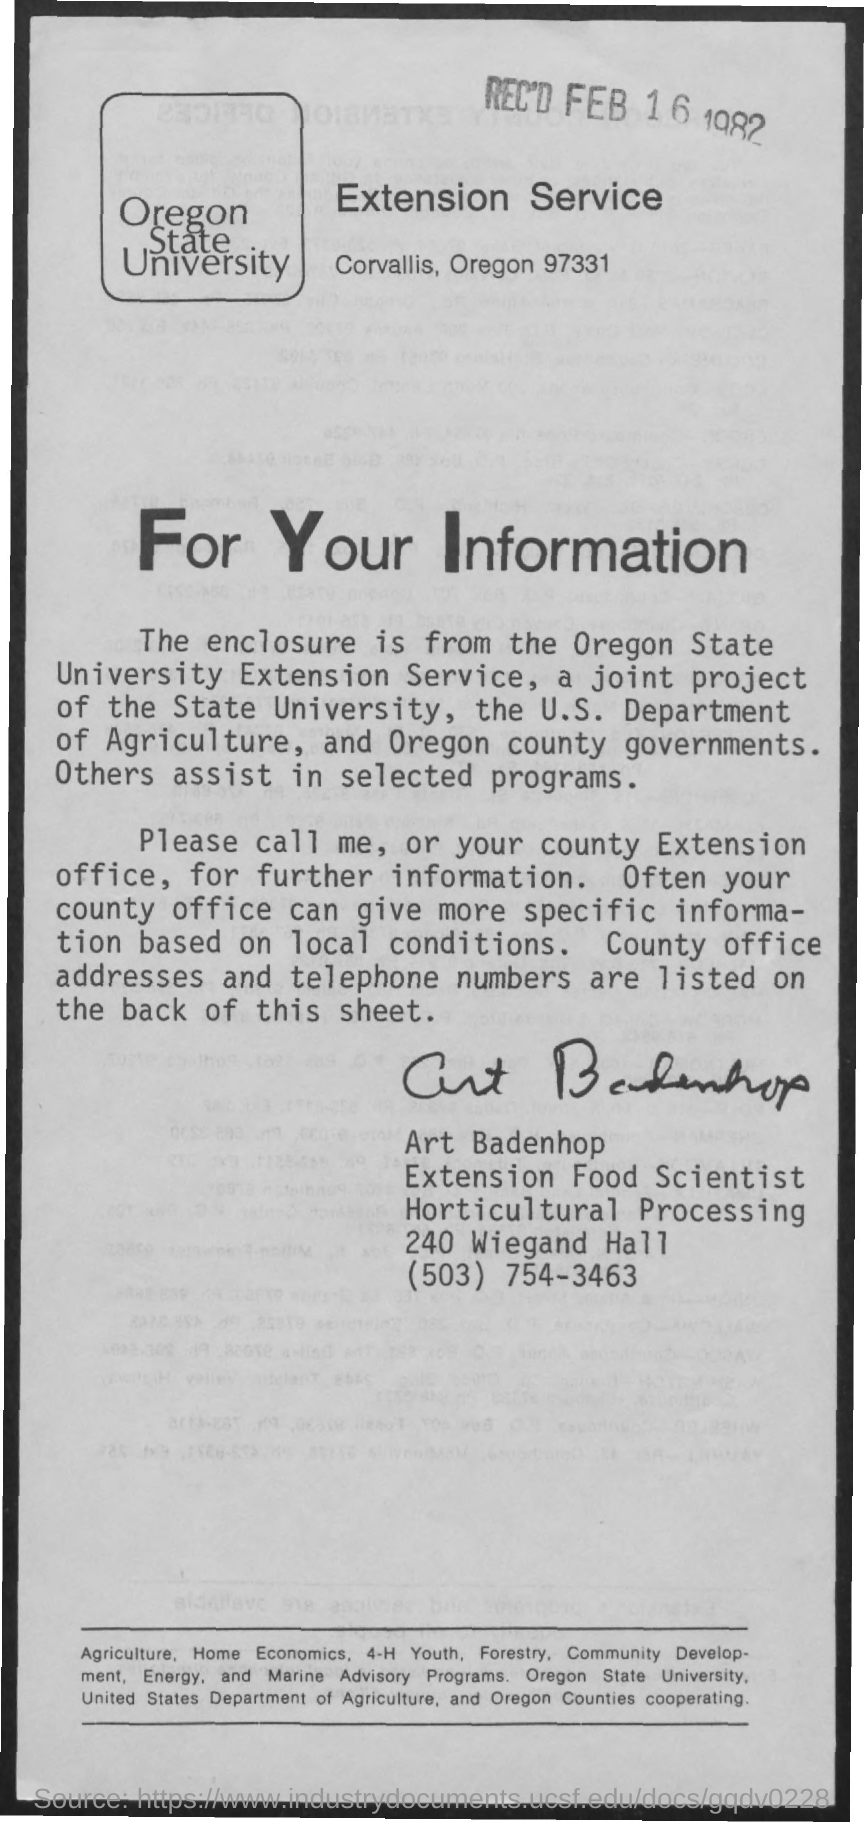Specify some key components in this picture. This letter is from Art Badenhop. The enclosure is from the Oregon State University Extension Service. 